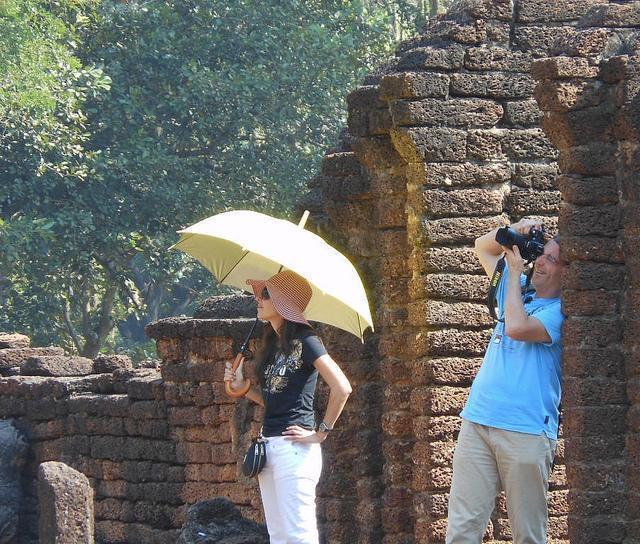What is he observing through the lens?
Select the accurate response from the four choices given to answer the question.
Options: Unseen, himself, woman, umbrella. Unseen. 